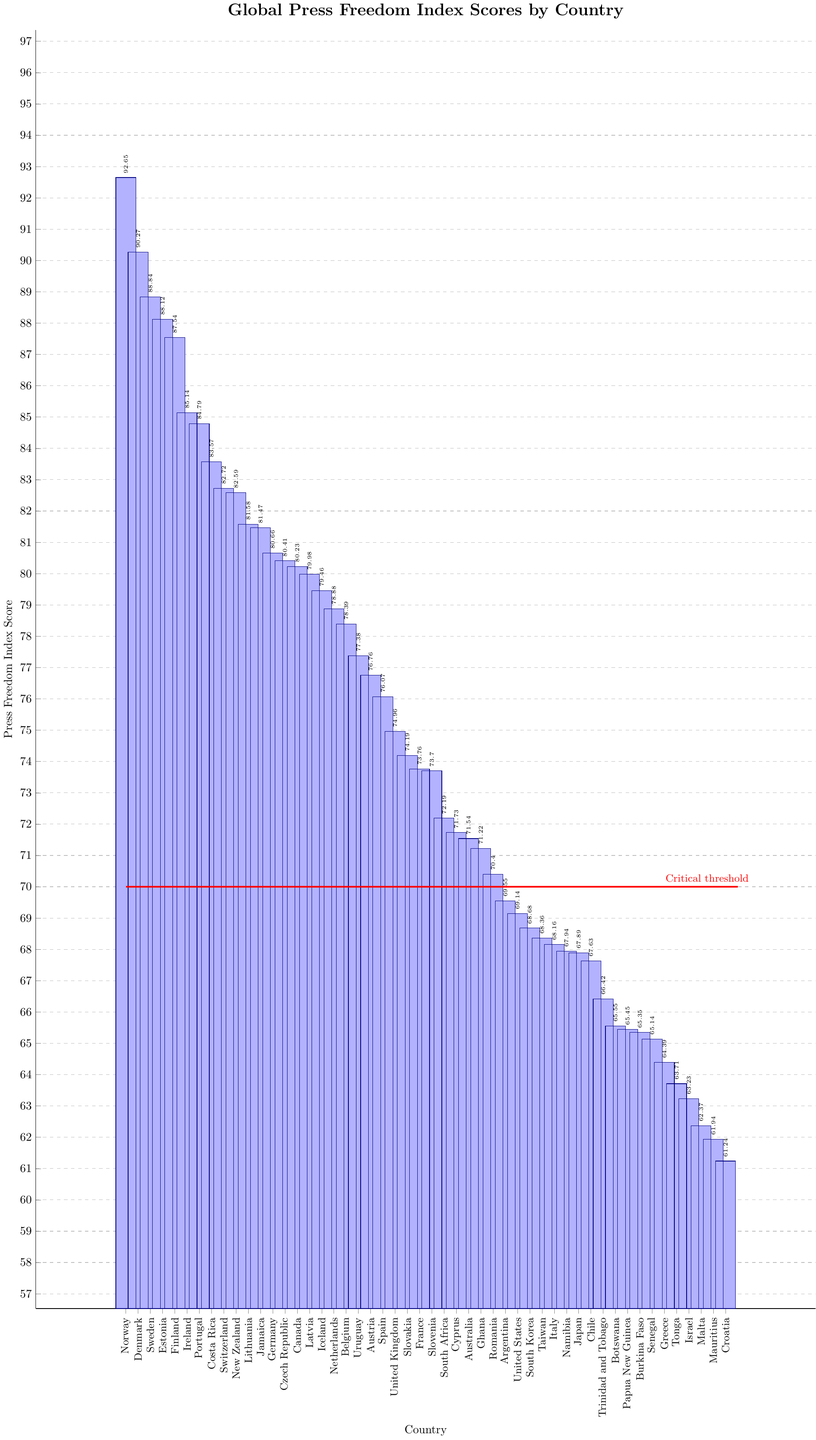Which country has the highest Press Freedom Index Score? By looking at the bar chart, the highest bar represents the country with the highest Press Freedom Index Score.
Answer: Norway Which country has the lowest Press Freedom Index Score? By identifying the shortest bar in the bar chart, we can determine which country has the lowest score.
Answer: Croatia How many countries have a Press Freedom Index Score above 80? Count the number of bars that extend above the 80 mark on the y-axis.
Answer: 15 Which countries have Press Freedom Index Scores between 70 and 75? Identify the bars that fall between the 70 and 75 range on the y-axis and look at their corresponding countries.
Answer: United Kingdom, Slovakia, France, Slovenia, South Africa, Cyprus, Australia, Ghana What is the approximate difference in Press Freedom Index Scores between Germany and the United States? Locate the bars for Germany and the United States and note their respective positions on the y-axis. Subtract the United States score from Germany's score (80.66 - 69.14).
Answer: 11.52 Which country has a slightly higher score: Spain or Belgium? Compare the heights of the bars corresponding to Spain and Belgium and determine which is slightly higher.
Answer: Belgium Is there any country in the top 10 that is not from Europe? Look at the bars representing the top 10 countries by height and check their names to see if any are non-European.
Answer: Costa Rica Between which two consecutive countries does the Press Freedom Index Score drop the most? Observe the heights of consecutive bars and identify where the largest change (drop) occurs.
Answer: New Zealand to Lithuania Which country’s score is closest to the "Critical threshold" line of 70? Look for the bar that is nearest to the horizontal line marked at the 70 level on the y-axis.
Answer: Romania How many countries have scores below the "Critical threshold" of 70? Count the number of bars that fall below the horizontal line marked at the 70 level on the y-axis.
Answer: 18 